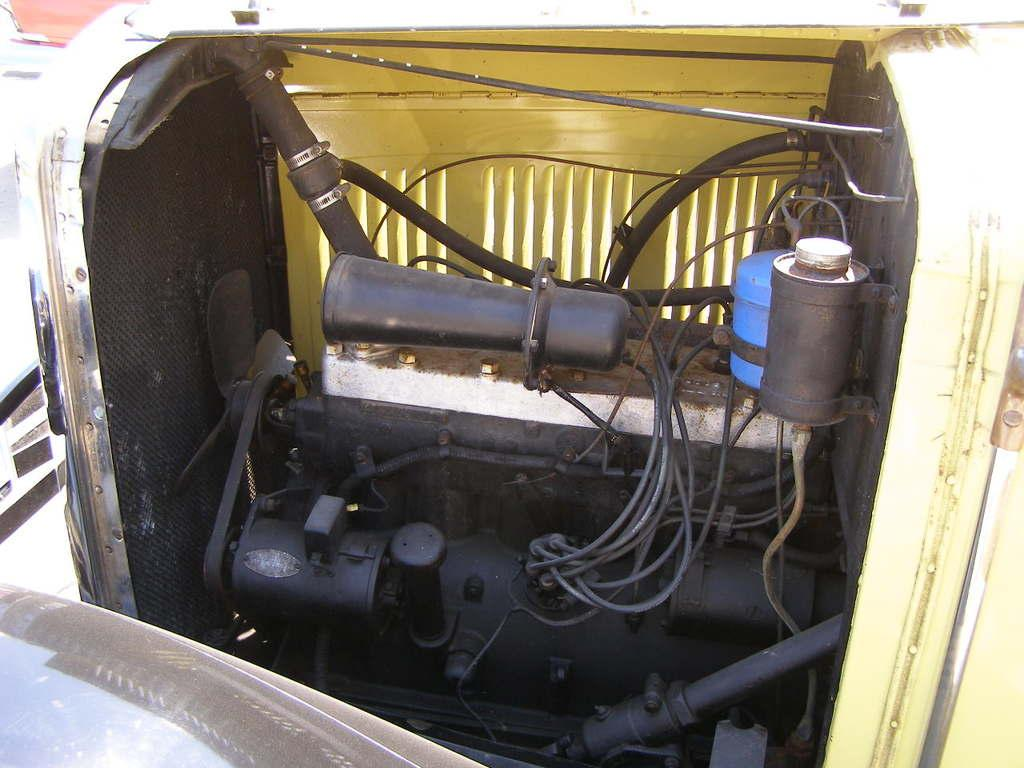What is the main subject of the image? The main subject of the image is an engine cabinet of a vehicle. What can be seen in the background of the image? There are objects in the background of the image. Is there anything at the bottom of the image? Yes, there is an object at the bottom of the image. Can you see a pet wearing a mask in the image? No, there is no pet wearing a mask in the image. 